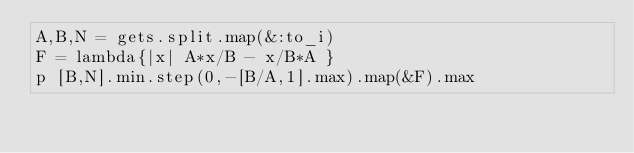Convert code to text. <code><loc_0><loc_0><loc_500><loc_500><_Ruby_>A,B,N = gets.split.map(&:to_i)
F = lambda{|x| A*x/B - x/B*A }
p [B,N].min.step(0,-[B/A,1].max).map(&F).max
</code> 